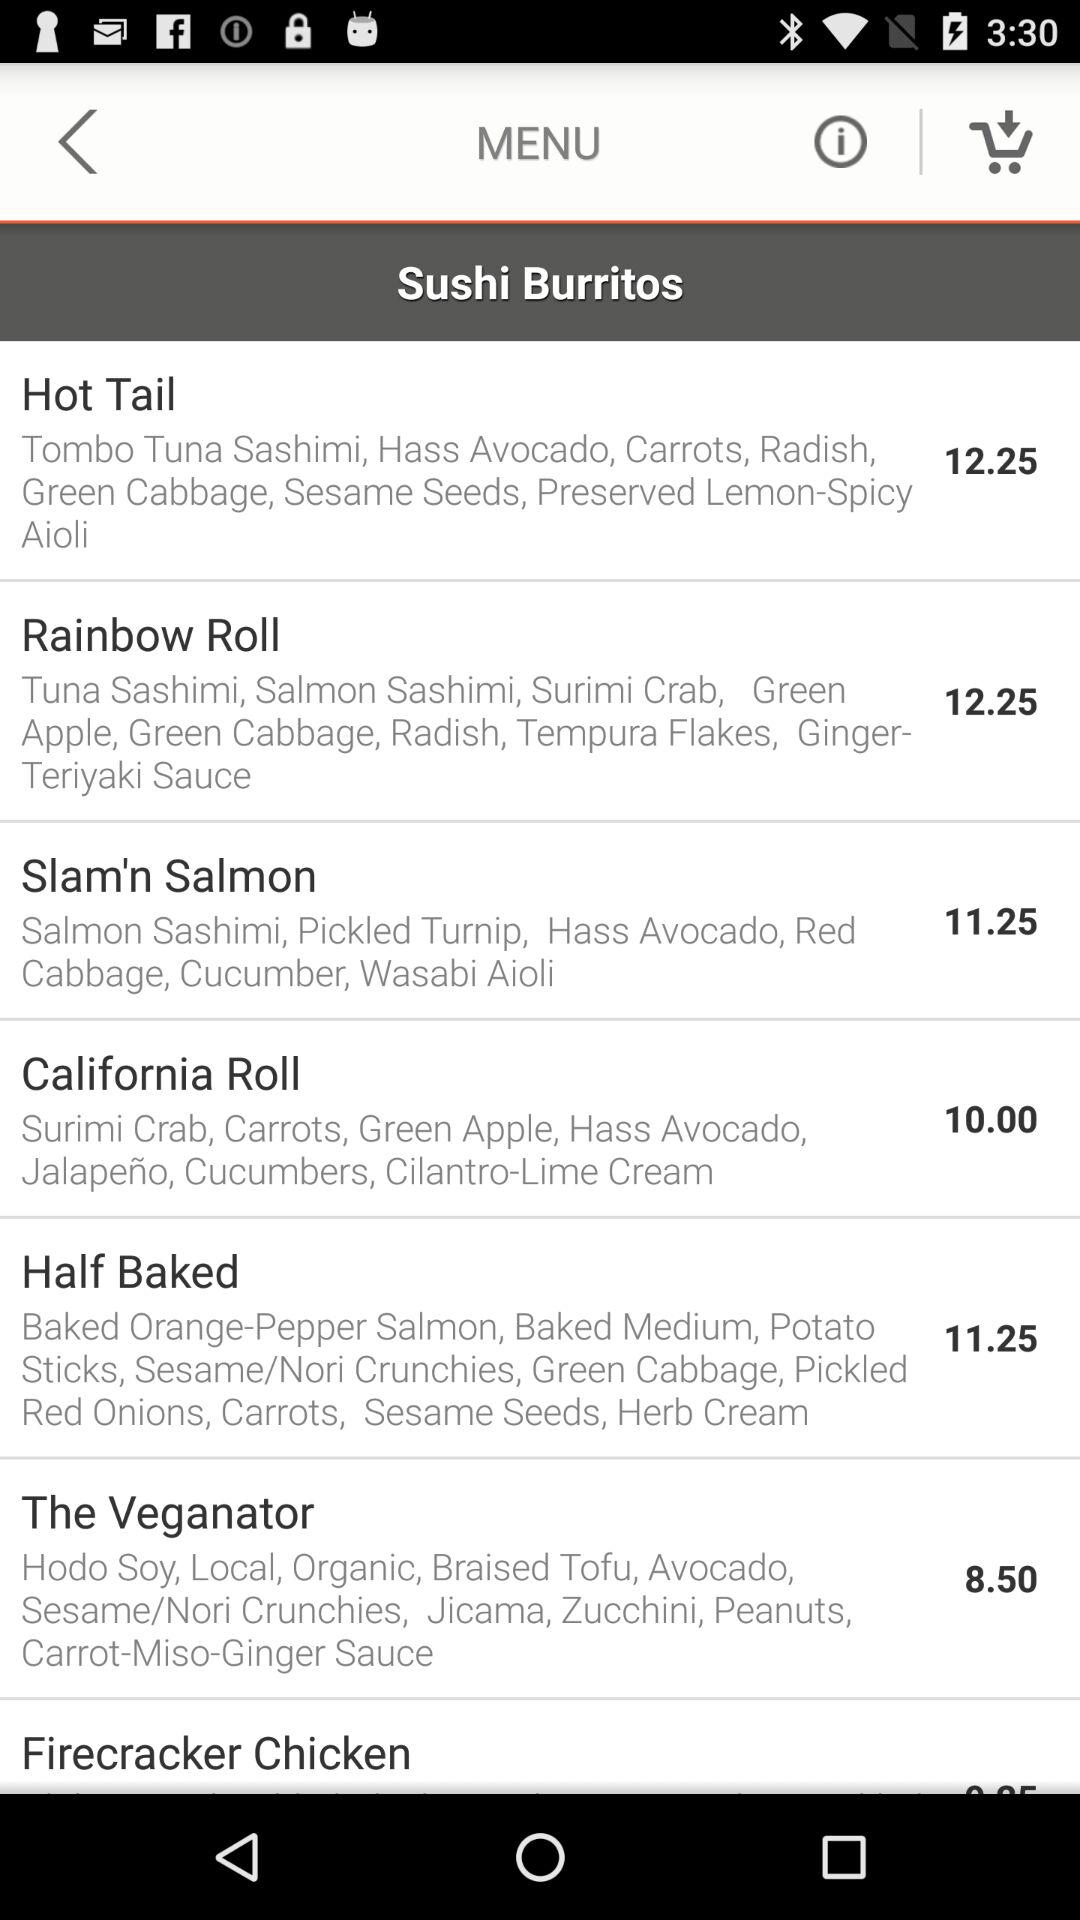What are the ingredients used to prepare the "Rainbow Roll"? The ingredients are tuna sashimi, salmon sashimi, surimi crab, green apple, green cabbage, radish, tempura flakes and ginger-teriyaki sauce. 